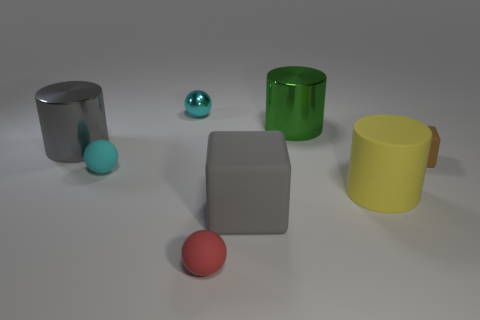How many gray metal cylinders are in front of the matte cube that is in front of the brown matte thing?
Ensure brevity in your answer.  0. Is the brown thing the same size as the gray metallic cylinder?
Your answer should be very brief. No. How many gray things are made of the same material as the yellow object?
Provide a succinct answer. 1. There is a red rubber thing that is the same shape as the tiny cyan metal thing; what size is it?
Provide a succinct answer. Small. Is the shape of the matte thing that is on the right side of the big yellow rubber cylinder the same as  the green metal object?
Make the answer very short. No. What shape is the big metallic object behind the big shiny cylinder that is to the left of the big matte cube?
Give a very brief answer. Cylinder. Is there any other thing that has the same shape as the tiny red matte thing?
Your response must be concise. Yes. What color is the big matte thing that is the same shape as the large gray metal thing?
Your answer should be compact. Yellow. There is a tiny metallic thing; is it the same color as the rubber ball behind the yellow matte cylinder?
Your response must be concise. Yes. There is a small object that is on the left side of the red rubber thing and in front of the small metallic thing; what shape is it?
Ensure brevity in your answer.  Sphere. 